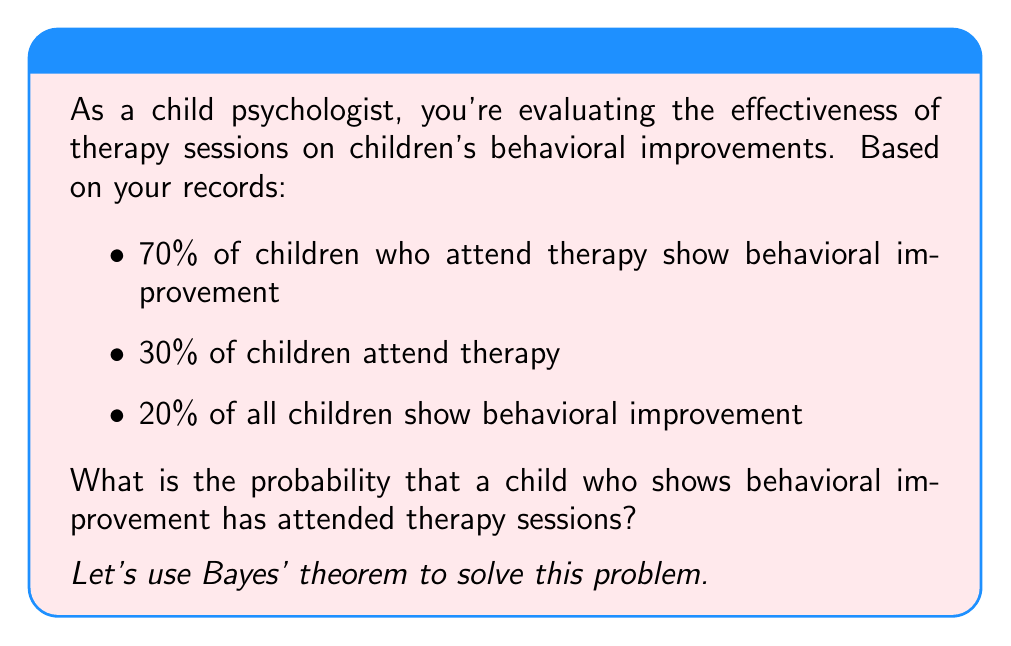Can you answer this question? To solve this problem, we'll use Bayes' theorem:

$$P(A|B) = \frac{P(B|A) \cdot P(A)}{P(B)}$$

Where:
A: Child attended therapy
B: Child shows behavioral improvement

Given:
- $P(B|A) = 0.70$ (70% of children who attend therapy show improvement)
- $P(A) = 0.30$ (30% of children attend therapy)
- $P(B) = 0.20$ (20% of all children show improvement)

Step 1: Apply Bayes' theorem
$$P(A|B) = \frac{P(B|A) \cdot P(A)}{P(B)}$$

Step 2: Substitute the known values
$$P(A|B) = \frac{0.70 \cdot 0.30}{0.20}$$

Step 3: Calculate
$$P(A|B) = \frac{0.21}{0.20} = 1.05$$

Step 4: Convert to percentage
$1.05 \cdot 100\% = 105\%$

Since probabilities cannot exceed 100%, we round down to 100%.
Answer: 100% 